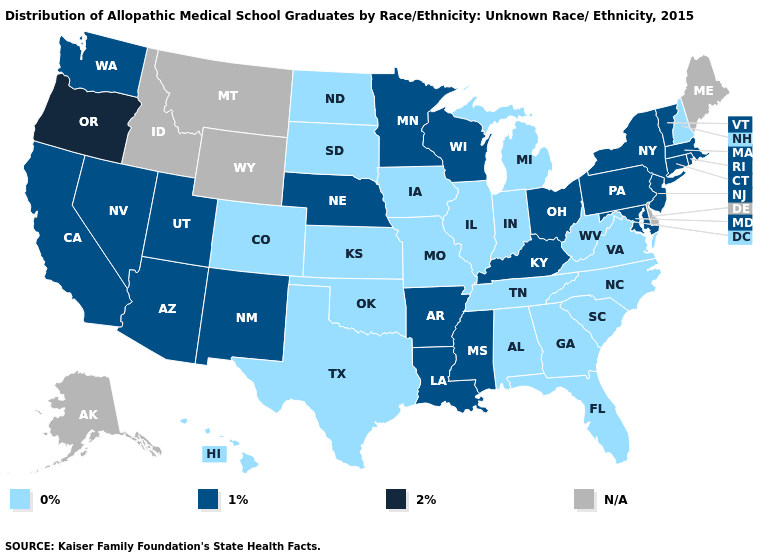What is the highest value in the USA?
Short answer required. 2%. What is the lowest value in the Northeast?
Keep it brief. 0%. What is the value of Montana?
Answer briefly. N/A. Does the first symbol in the legend represent the smallest category?
Be succinct. Yes. What is the value of Wyoming?
Quick response, please. N/A. What is the value of Massachusetts?
Be succinct. 1%. Does Missouri have the lowest value in the USA?
Write a very short answer. Yes. Name the states that have a value in the range 0%?
Write a very short answer. Alabama, Colorado, Florida, Georgia, Hawaii, Illinois, Indiana, Iowa, Kansas, Michigan, Missouri, New Hampshire, North Carolina, North Dakota, Oklahoma, South Carolina, South Dakota, Tennessee, Texas, Virginia, West Virginia. Does Colorado have the lowest value in the West?
Write a very short answer. Yes. What is the value of Idaho?
Concise answer only. N/A. What is the highest value in states that border Utah?
Write a very short answer. 1%. Is the legend a continuous bar?
Answer briefly. No. What is the value of Colorado?
Concise answer only. 0%. What is the lowest value in the USA?
Short answer required. 0%. 